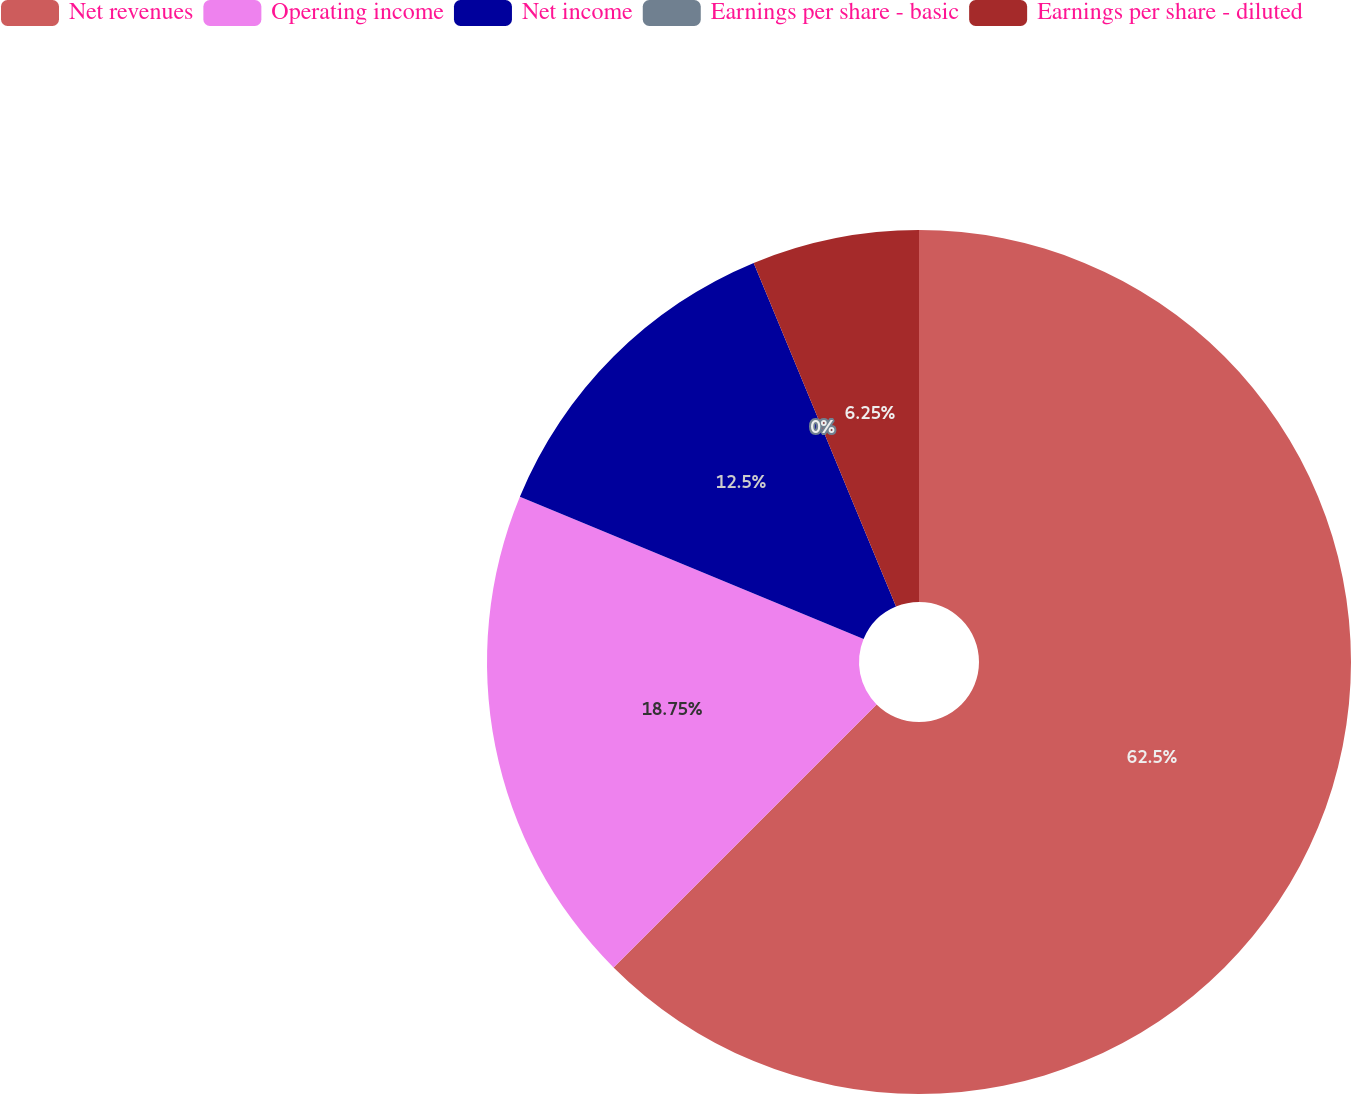<chart> <loc_0><loc_0><loc_500><loc_500><pie_chart><fcel>Net revenues<fcel>Operating income<fcel>Net income<fcel>Earnings per share - basic<fcel>Earnings per share - diluted<nl><fcel>62.5%<fcel>18.75%<fcel>12.5%<fcel>0.0%<fcel>6.25%<nl></chart> 